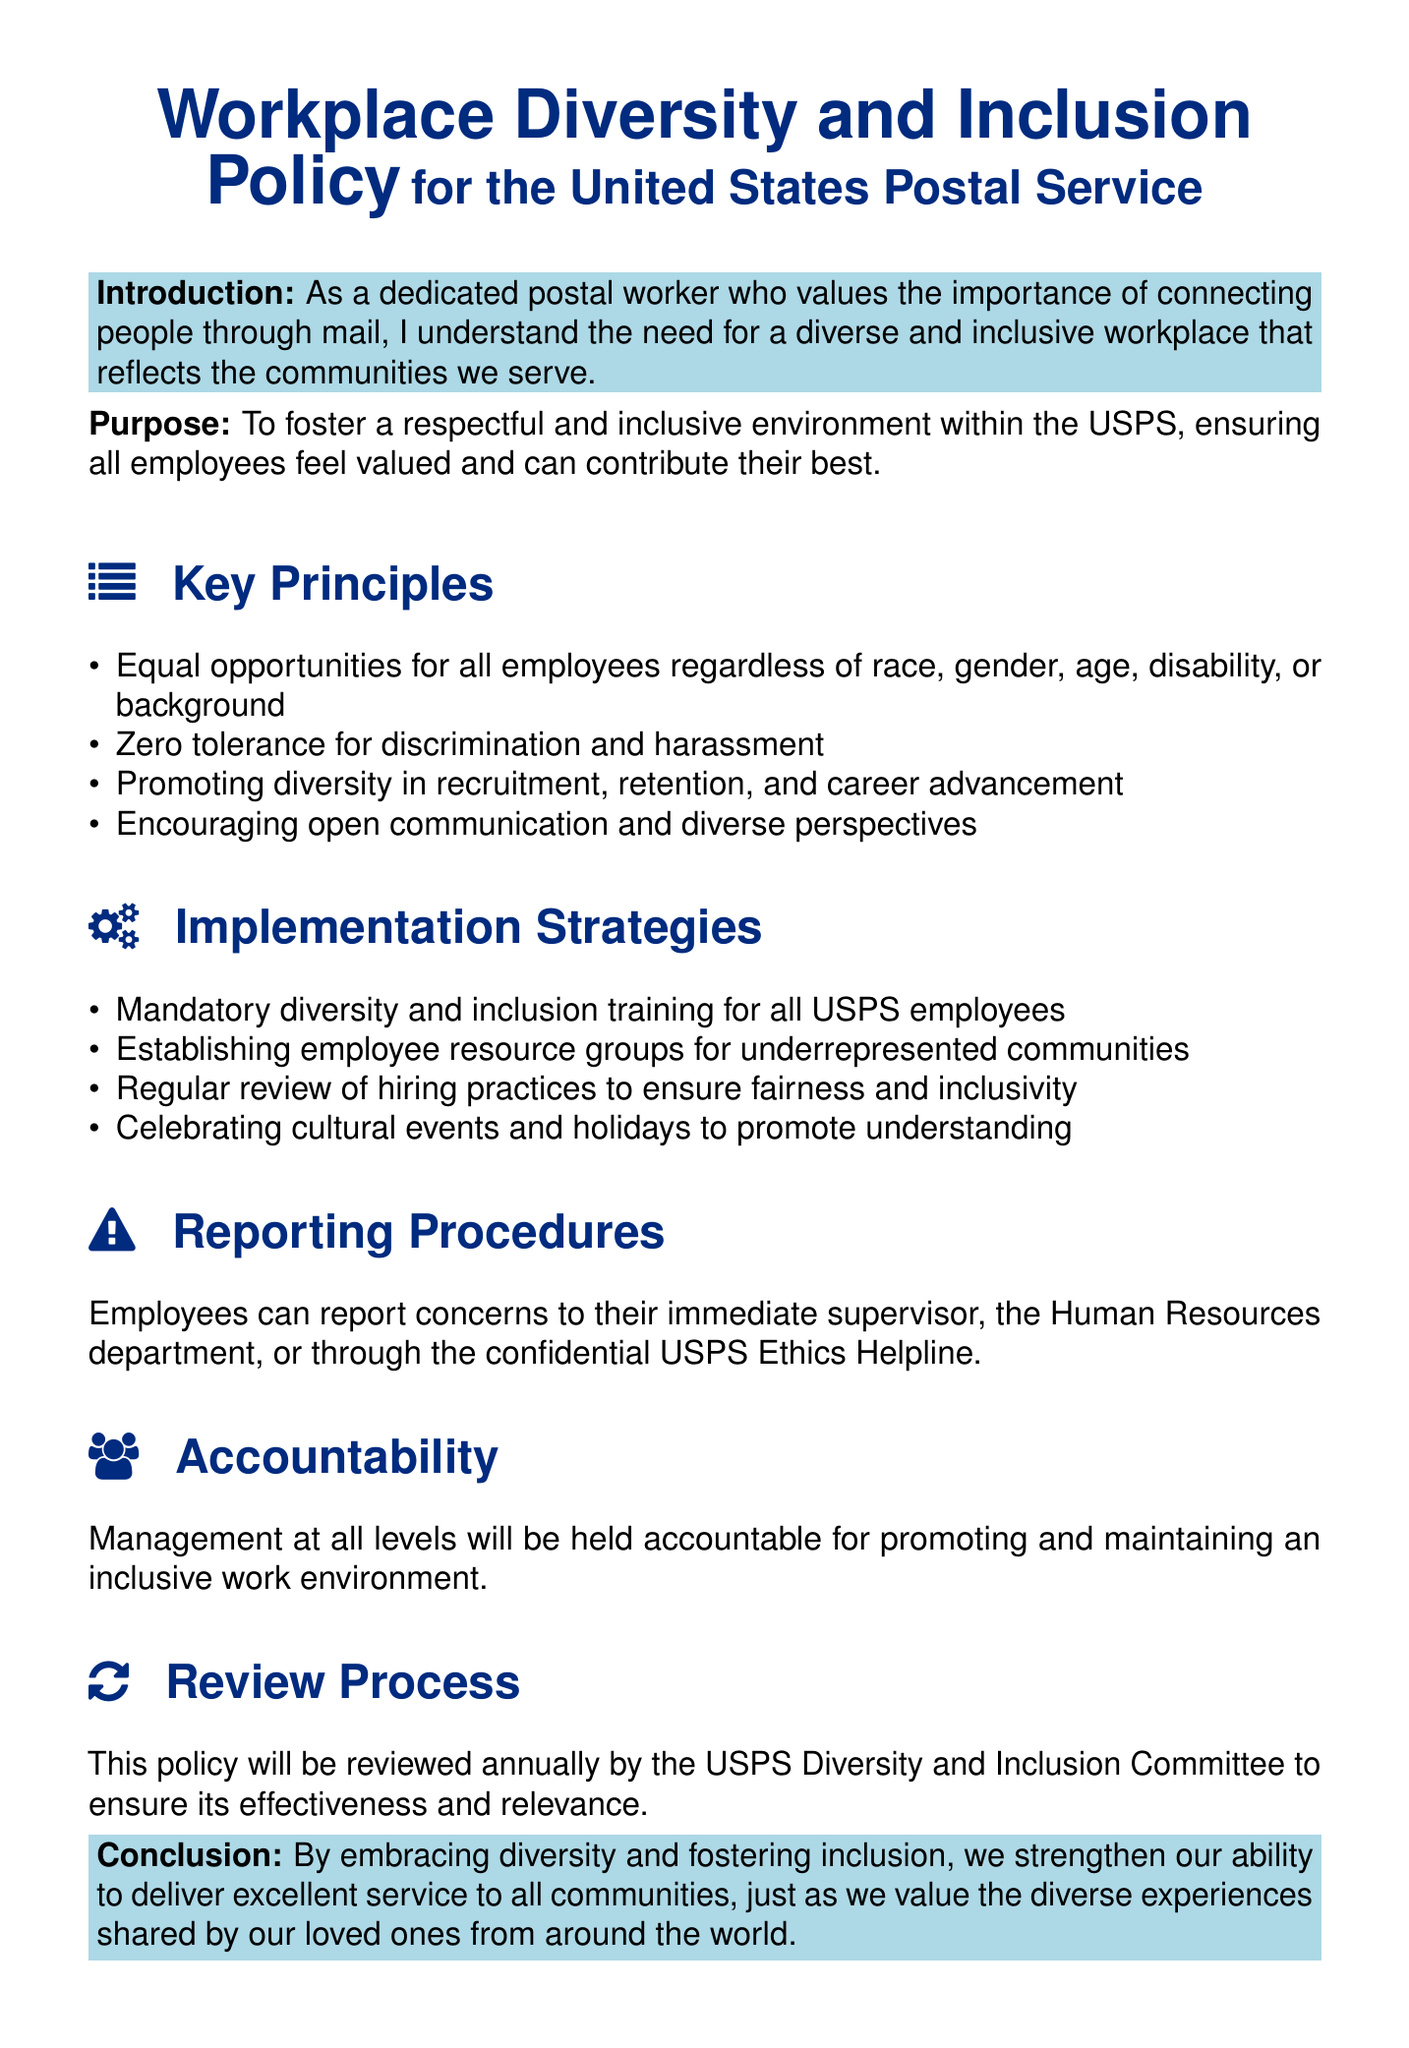What is the purpose of the policy? The purpose is to foster a respectful and inclusive environment within the USPS, ensuring all employees feel valued and can contribute their best.
Answer: To foster a respectful and inclusive environment What are the key principles of the policy? The key principles include equal opportunities, zero tolerance for discrimination, promoting diversity in recruitment, and encouraging open communication.
Answer: Equal opportunities, zero tolerance for discrimination, promoting diversity, encouraging open communication How often will the policy be reviewed? The document states that the policy will be reviewed annually.
Answer: Annually Who can employees report concerns to? Employees can report concerns to their immediate supervisor, the Human Resources department, or through the USPS Ethics Helpline.
Answer: Supervisor, Human Resources, USPS Ethics Helpline What is one of the implementation strategies mentioned? One of the implementation strategies is mandatory diversity and inclusion training for all USPS employees.
Answer: Mandatory diversity and inclusion training What does the document state about management accountability? It states that management at all levels will be held accountable for promoting and maintaining an inclusive work environment.
Answer: Management will be held accountable What kind of training is required for employees? The document specifies mandatory diversity and inclusion training for all USPS employees.
Answer: Mandatory diversity and inclusion training How does the policy relate to delivering service? The conclusion states that embracing diversity strengthens the ability to deliver excellent service to all communities.
Answer: Strengthens ability to deliver excellent service 